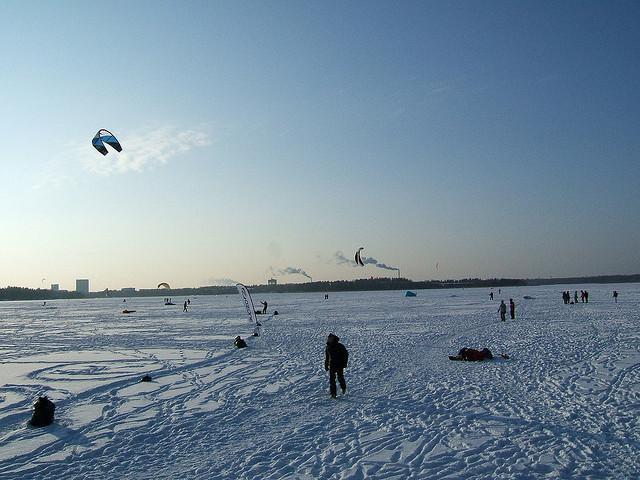How many elephants can be seen?
Give a very brief answer. 0. 